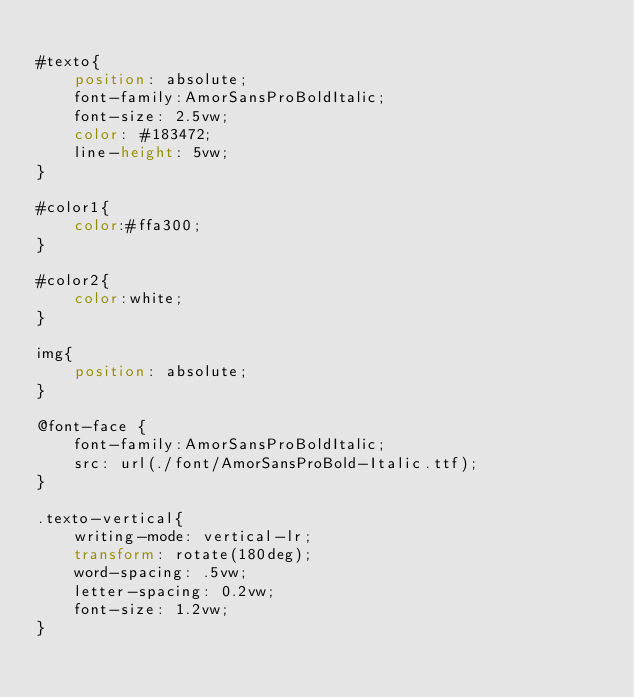<code> <loc_0><loc_0><loc_500><loc_500><_CSS_>
#texto{
    position: absolute;
    font-family:AmorSansProBoldItalic;
    font-size: 2.5vw;
    color: #183472;
    line-height: 5vw;
}

#color1{
    color:#ffa300;
}

#color2{
    color:white;
}

img{
    position: absolute;
}

@font-face {
    font-family:AmorSansProBoldItalic;
    src: url(./font/AmorSansProBold-Italic.ttf);
}

.texto-vertical{
    writing-mode: vertical-lr;
    transform: rotate(180deg);
    word-spacing: .5vw;
    letter-spacing: 0.2vw;
    font-size: 1.2vw;
}</code> 